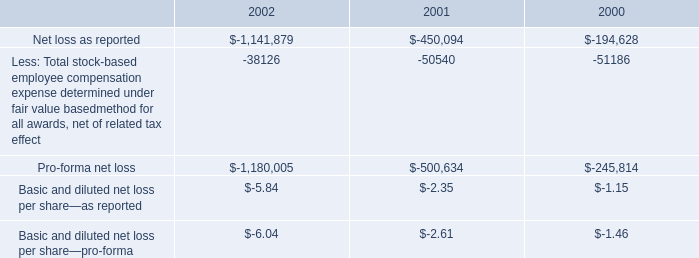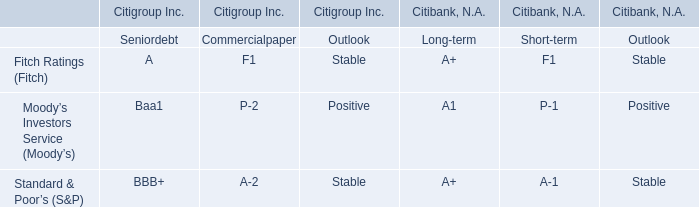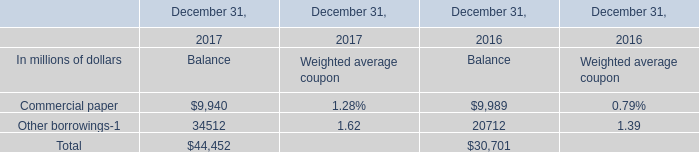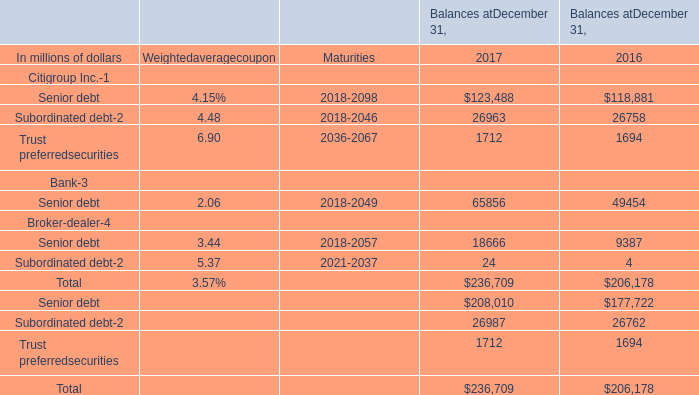What's the increasing rate of Other borrowings for Balance in 2017? 
Computations: ((34512 - 20712) / 20712)
Answer: 0.66628. 